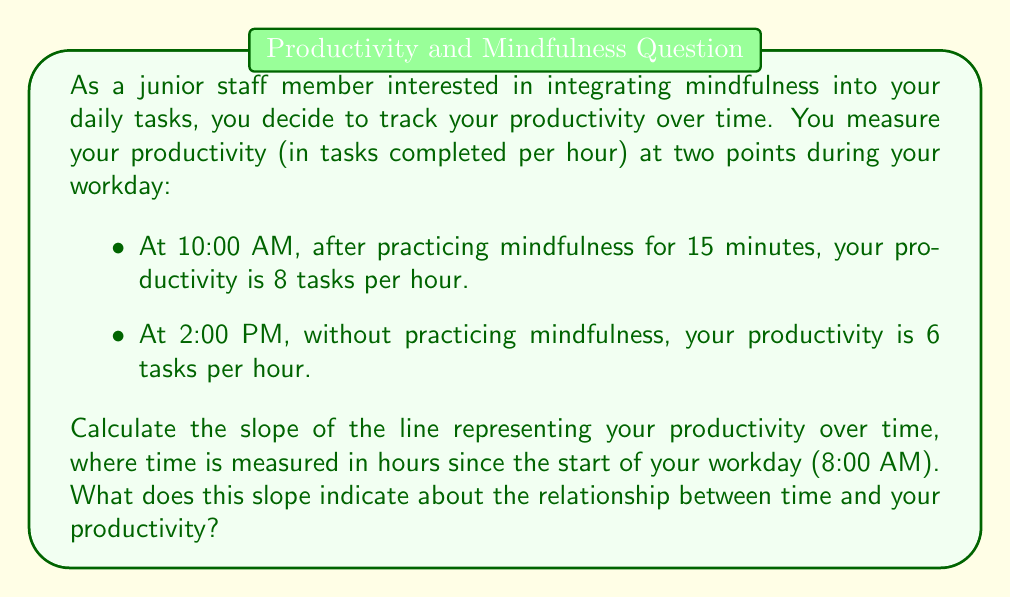Help me with this question. To calculate the slope of the line representing productivity over time, we'll use the slope formula:

$$ m = \frac{y_2 - y_1}{x_2 - x_1} $$

Where:
- $m$ is the slope
- $(x_1, y_1)$ is the first point
- $(x_2, y_2)$ is the second point

Let's identify our points:
1. At 10:00 AM (2 hours after 8:00 AM): $(x_1, y_1) = (2, 8)$
2. At 2:00 PM (6 hours after 8:00 AM): $(x_2, y_2) = (6, 6)$

Now, let's plug these values into the slope formula:

$$ m = \frac{y_2 - y_1}{x_2 - x_1} = \frac{6 - 8}{6 - 2} = \frac{-2}{4} = -0.5 $$

The slope is -0.5 tasks per hour per hour.

This negative slope indicates that your productivity is decreasing over time. Specifically, for each hour that passes, your productivity decreases by 0.5 tasks per hour.

This result suggests that practicing mindfulness at the start of your day may have a positive impact on your productivity, as your productivity was higher after the mindfulness session and decreased as the day progressed without further mindfulness practice.
Answer: The slope of the line representing productivity over time is -0.5 tasks per hour per hour. 